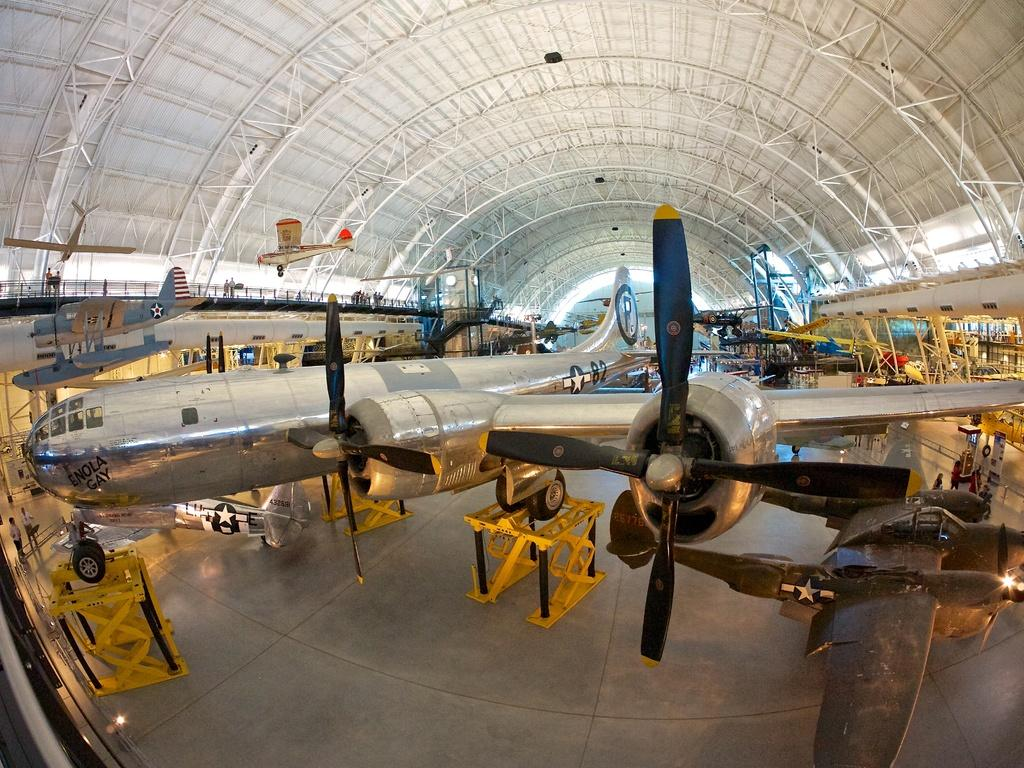What is the main subject of the image? The main subject of the image is many planes with logos. What can be seen on the ground in the image? There are yellow color stands on the ground in the image. What is present on the ceiling in the image? There are rods on the ceiling in the image. Where is the patch of grass located in the image? There is no patch of grass present in the image. What type of coat can be seen hanging on the wall in the image? There is no coat present in the image. 